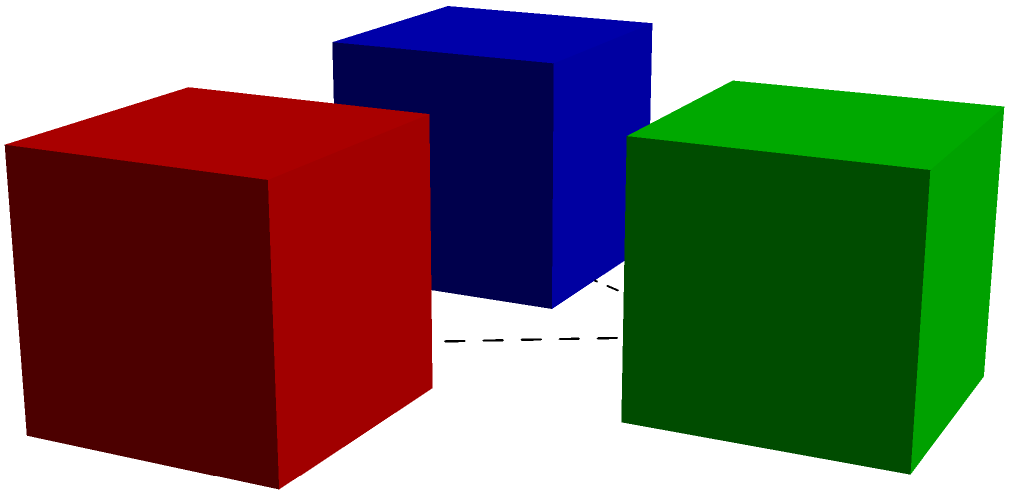In a secure data transmission system, three encrypted data packets are represented by the 3D cubes A, B, and C. The system rotates these packets in 3D space as part of its encryption protocol. If the system performs a 120° clockwise rotation around the axis perpendicular to the plane containing the centers of A, B, and C, what will be the new position of cube B? To solve this problem, we need to follow these steps:

1. Understand the initial configuration:
   - Cube A is at (0,0,0)
   - Cube B is at (2,0,0)
   - Cube C is at (1,1.732,0)

2. Identify the rotation axis:
   - The axis is perpendicular to the plane containing the centers of A, B, and C
   - This axis passes through the centroid of the triangle formed by A, B, and C

3. Calculate the rotation:
   - A 120° clockwise rotation is equivalent to a 240° counterclockwise rotation
   - In a 120° rotation, each point moves to the position of the next point in the sequence

4. Determine the new position:
   - After the rotation, B will move to the position initially occupied by C
   - The coordinates of C are (1,1.732,0)

Therefore, after the 120° clockwise rotation, cube B will be at the position (1,1.732,0).
Answer: (1,1.732,0) 